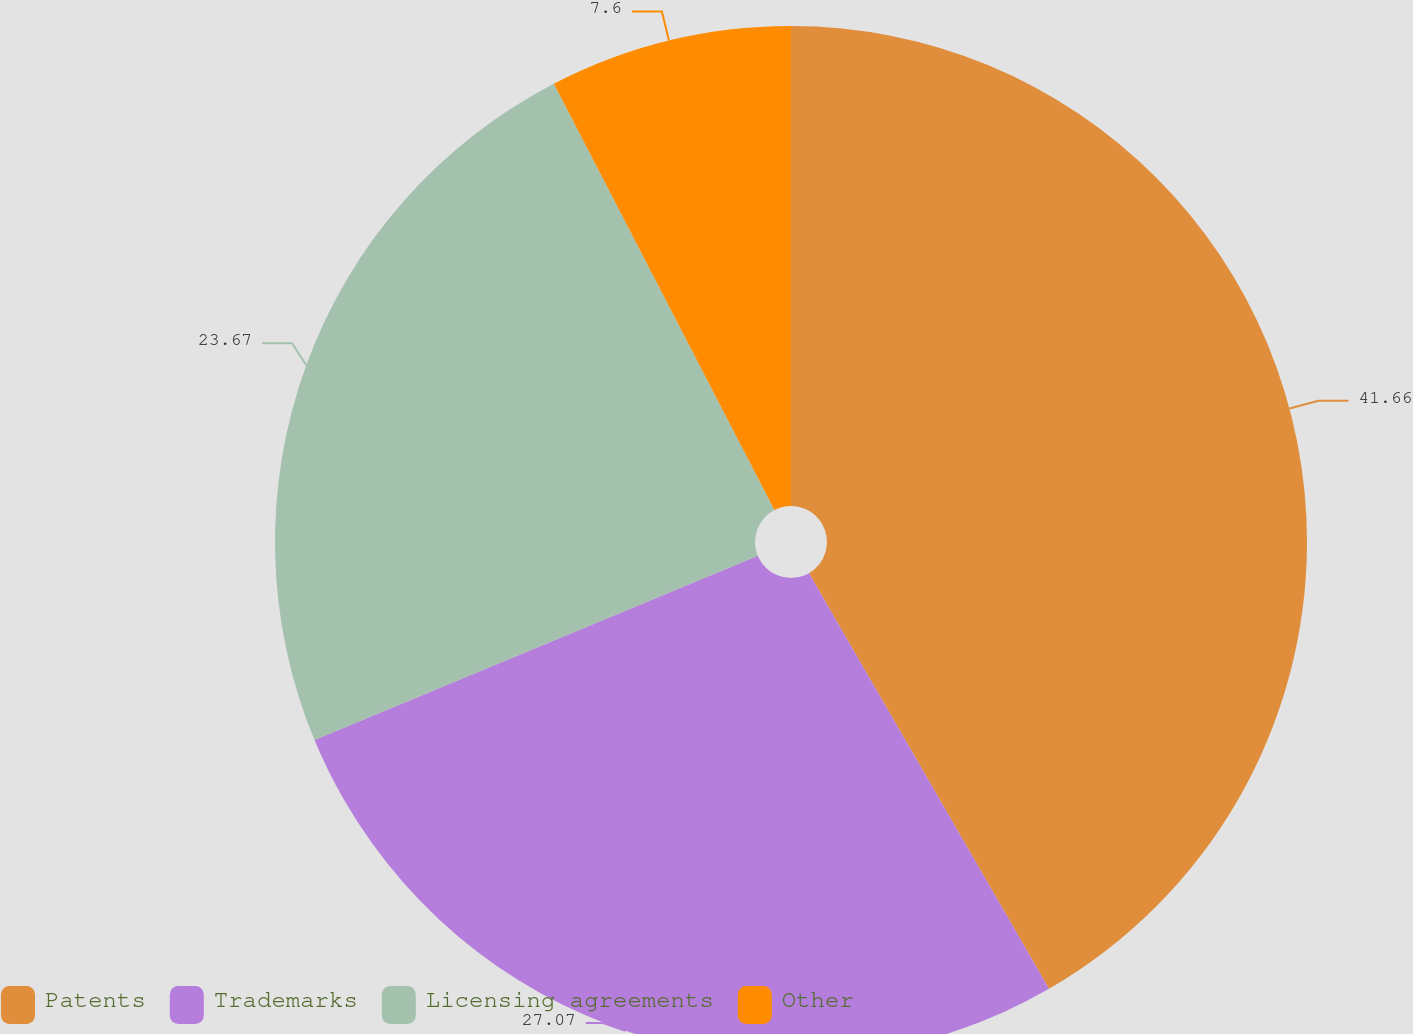Convert chart to OTSL. <chart><loc_0><loc_0><loc_500><loc_500><pie_chart><fcel>Patents<fcel>Trademarks<fcel>Licensing agreements<fcel>Other<nl><fcel>41.67%<fcel>27.07%<fcel>23.67%<fcel>7.6%<nl></chart> 